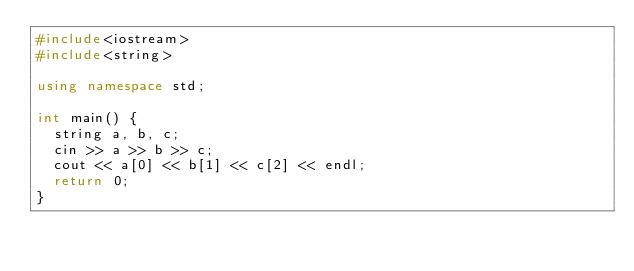<code> <loc_0><loc_0><loc_500><loc_500><_C++_>#include<iostream>
#include<string>

using namespace std;

int main() {
	string a, b, c;
	cin >> a >> b >> c;
	cout << a[0] << b[1] << c[2] << endl;
	return 0;
}</code> 